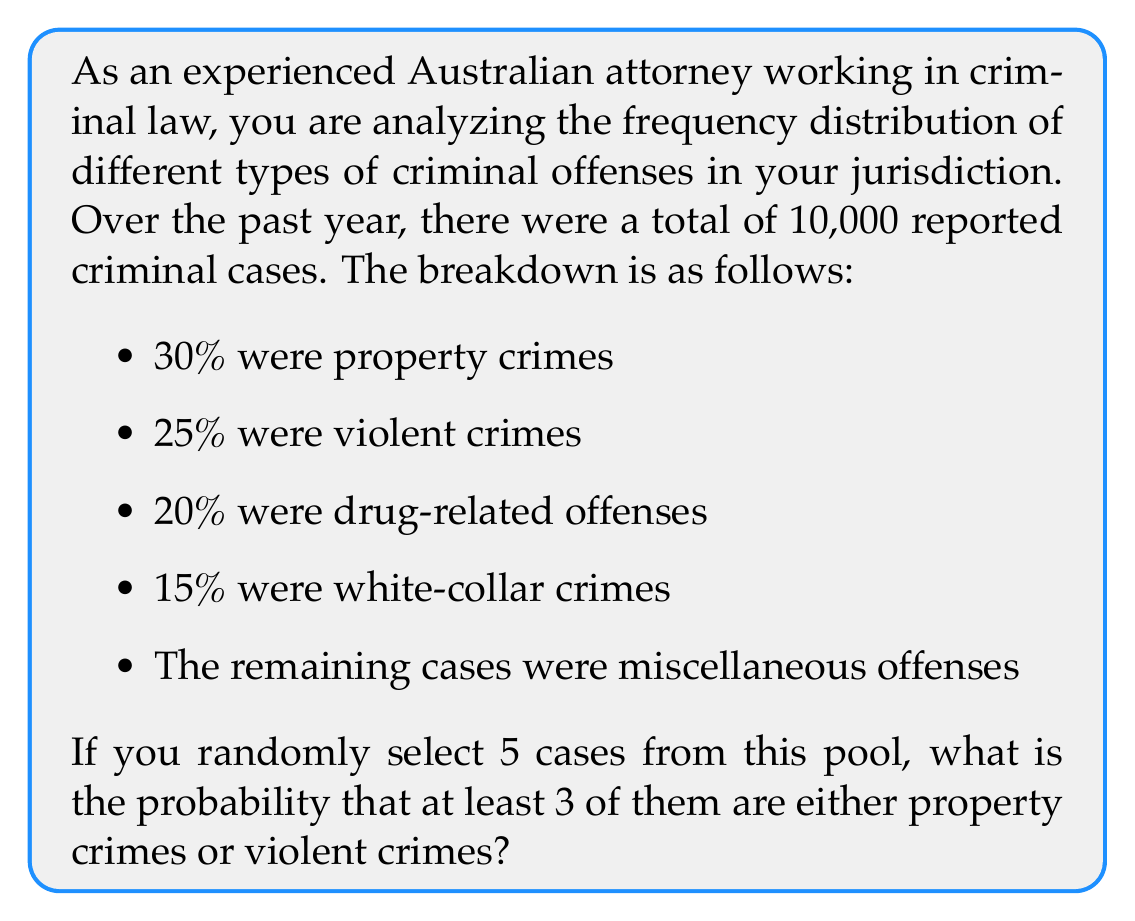Help me with this question. Let's approach this step-by-step:

1) First, we need to calculate the probability of a case being either a property crime or a violent crime:
   $p(\text{property or violent}) = 0.30 + 0.25 = 0.55$

2) The probability of a case not being a property or violent crime is:
   $1 - 0.55 = 0.45$

3) Now, we're looking for the probability of at least 3 out of 5 cases being property or violent crimes. This can happen in three ways:
   - Exactly 3 out of 5
   - Exactly 4 out of 5
   - All 5 out of 5

4) We can use the binomial probability formula for each of these scenarios:

   $$P(X = k) = \binom{n}{k} p^k (1-p)^{n-k}$$

   Where $n = 5$, $p = 0.55$, and $k = 3, 4, \text{ or } 5$

5) Calculating each probability:

   For 3 out of 5: $P(X = 3) = \binom{5}{3} (0.55)^3 (0.45)^2 = 10 \cdot 0.166375 \cdot 0.2025 = 0.3369$

   For 4 out of 5: $P(X = 4) = \binom{5}{4} (0.55)^4 (0.45)^1 = 5 \cdot 0.091506 \cdot 0.45 = 0.2059$

   For 5 out of 5: $P(X = 5) = \binom{5}{5} (0.55)^5 (0.45)^0 = 1 \cdot 0.050328 \cdot 1 = 0.0503$

6) The total probability is the sum of these individual probabilities:

   $P(\text{at least 3}) = 0.3369 + 0.2059 + 0.0503 = 0.5931$
Answer: The probability that at least 3 out of 5 randomly selected cases are either property crimes or violent crimes is approximately 0.5931 or 59.31%. 